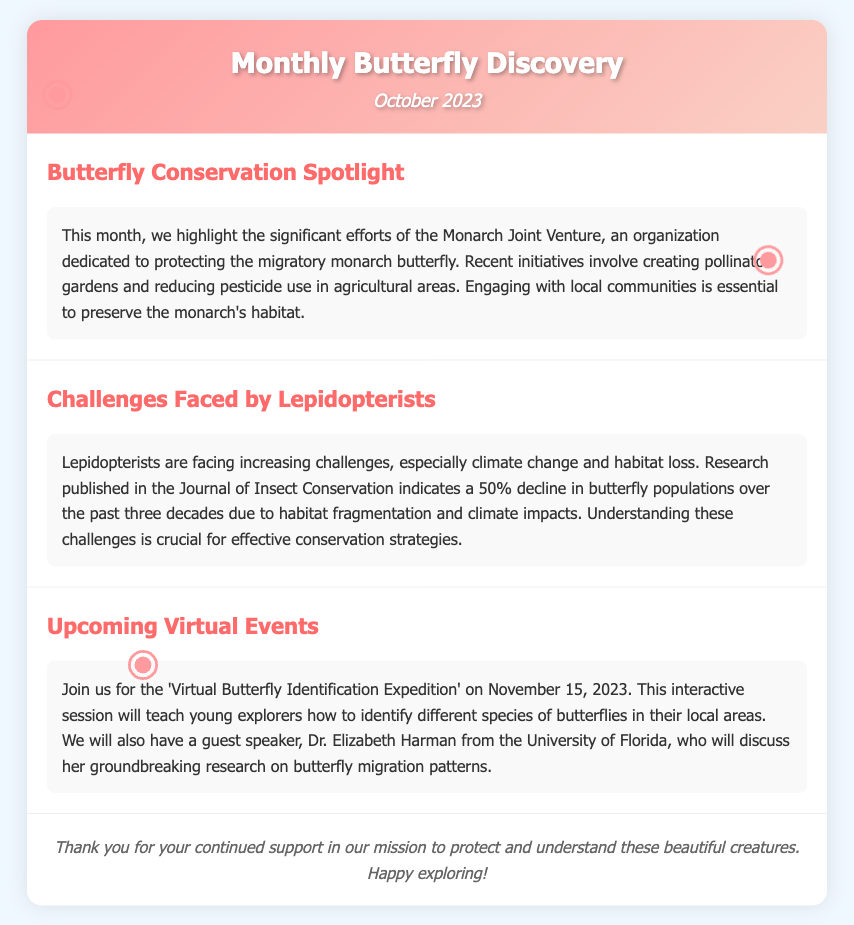What is the title of the newsletter? The title of the newsletter is presented prominently at the top of the document.
Answer: Monthly Butterfly Discovery What organization is highlighted for butterfly conservation? The document specifically mentions an organization working on monarch butterfly conservation efforts.
Answer: Monarch Joint Venture What is the percentage decline in butterfly populations over the past three decades? The document contains research findings on butterfly population decline, specifically citing a percentage.
Answer: 50% When will the Virtual Butterfly Identification Expedition take place? The newsletter provides a clear date for the upcoming virtual event.
Answer: November 15, 2023 Who is the guest speaker for the upcoming event? The document includes information about a guest speaker at the event, detailing her credentials.
Answer: Dr. Elizabeth Harman What is one of the main challenges lepidopterists are facing? The document outlines specific challenges faced by lepidopterists, calling out a significant threat.
Answer: Climate change What types of initiatives does the Monarch Joint Venture engage in? The newsletter mentions specific activities undertaken by the organization to protect butterflies.
Answer: Pollinator gardens What is the focus of this month’s newsletter? A summary of the primary theme covered in the newsletter helps identify its purpose.
Answer: Conservation and Challenges 